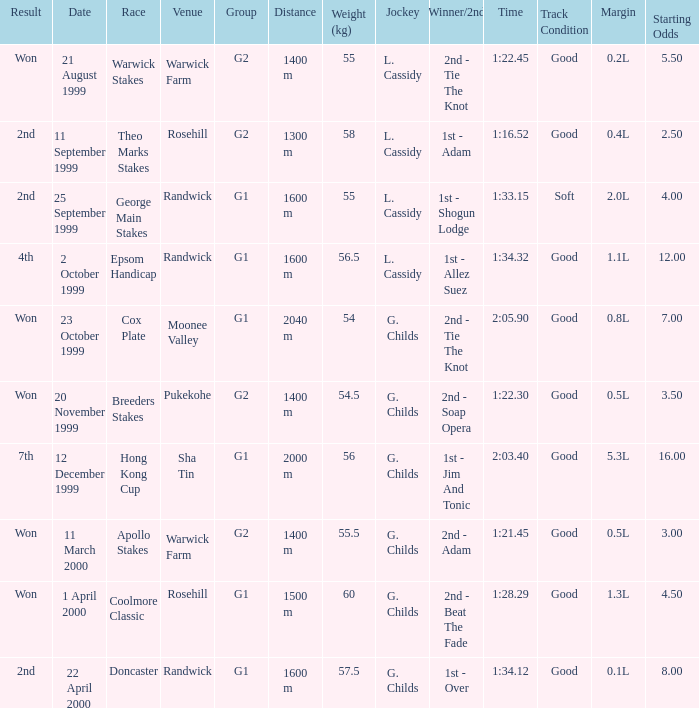How man teams had a total weight of 57.5? 1.0. 